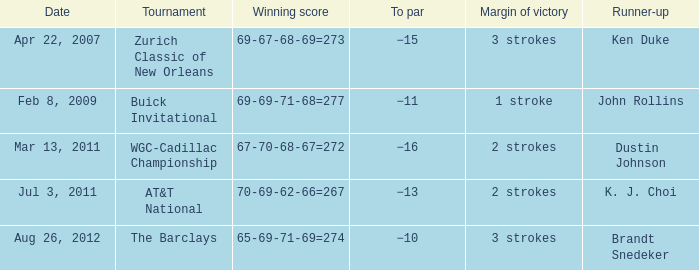A tournament on which date has a margin of victory of 2 strokes and a par of −16? Mar 13, 2011. 